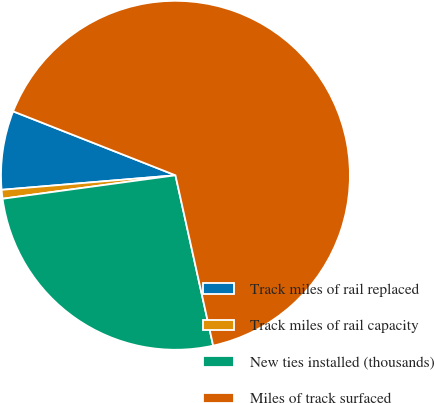Convert chart. <chart><loc_0><loc_0><loc_500><loc_500><pie_chart><fcel>Track miles of rail replaced<fcel>Track miles of rail capacity<fcel>New ties installed (thousands)<fcel>Miles of track surfaced<nl><fcel>7.3%<fcel>0.82%<fcel>26.32%<fcel>65.56%<nl></chart> 